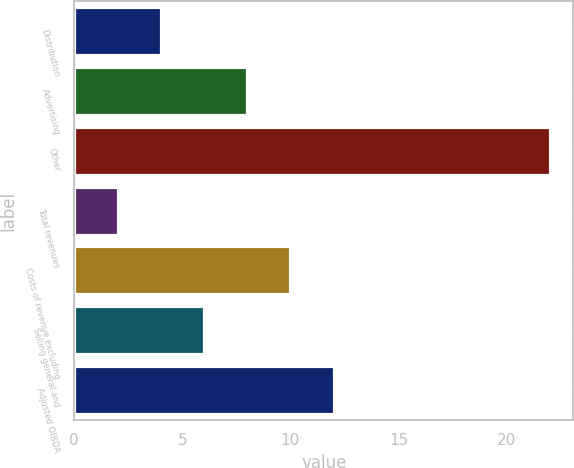Convert chart. <chart><loc_0><loc_0><loc_500><loc_500><bar_chart><fcel>Distribution<fcel>Advertising<fcel>Other<fcel>Total revenues<fcel>Costs of revenue excluding<fcel>Selling general and<fcel>Adjusted OIBDA<nl><fcel>4<fcel>8<fcel>22<fcel>2<fcel>10<fcel>6<fcel>12<nl></chart> 